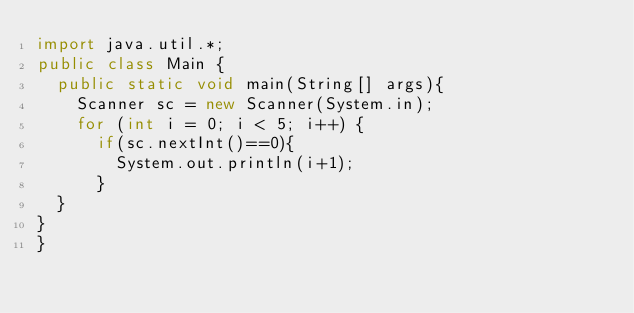<code> <loc_0><loc_0><loc_500><loc_500><_Java_>import java.util.*;
public class Main {
	public static void main(String[] args){
		Scanner sc = new Scanner(System.in);
		for (int i = 0; i < 5; i++) {
			if(sc.nextInt()==0){
				System.out.println(i+1);
			}
	}
}
}</code> 